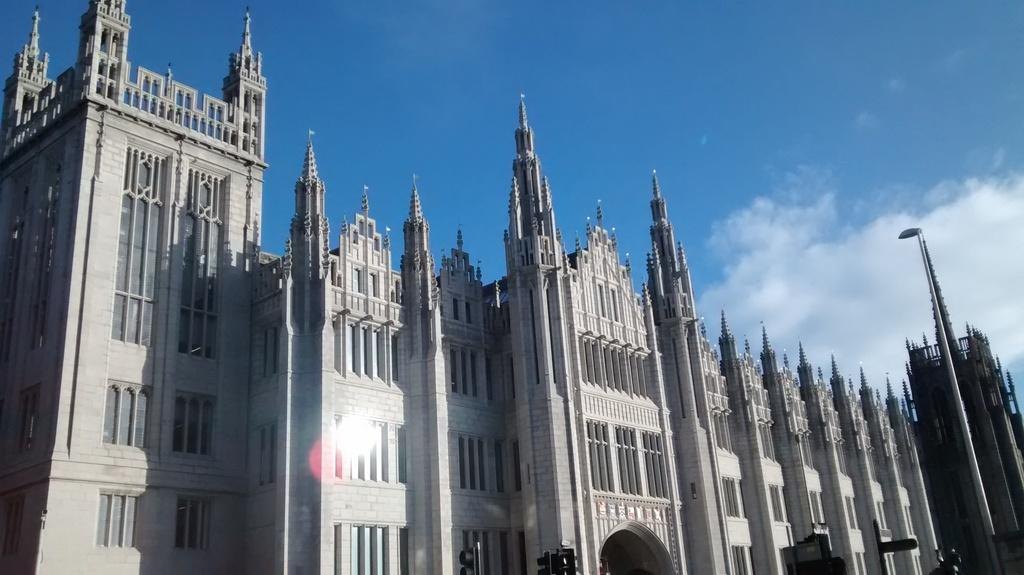Where was the image taken? The image was taken outside. What can be seen in the middle of the image? There is a building in the middle of the image. What is visible at the top of the image? The sky is visible at the top of the image. What type of distribution system is being used by the building in the image? There is no information about a distribution system in the image, as it only shows a building and the sky. 